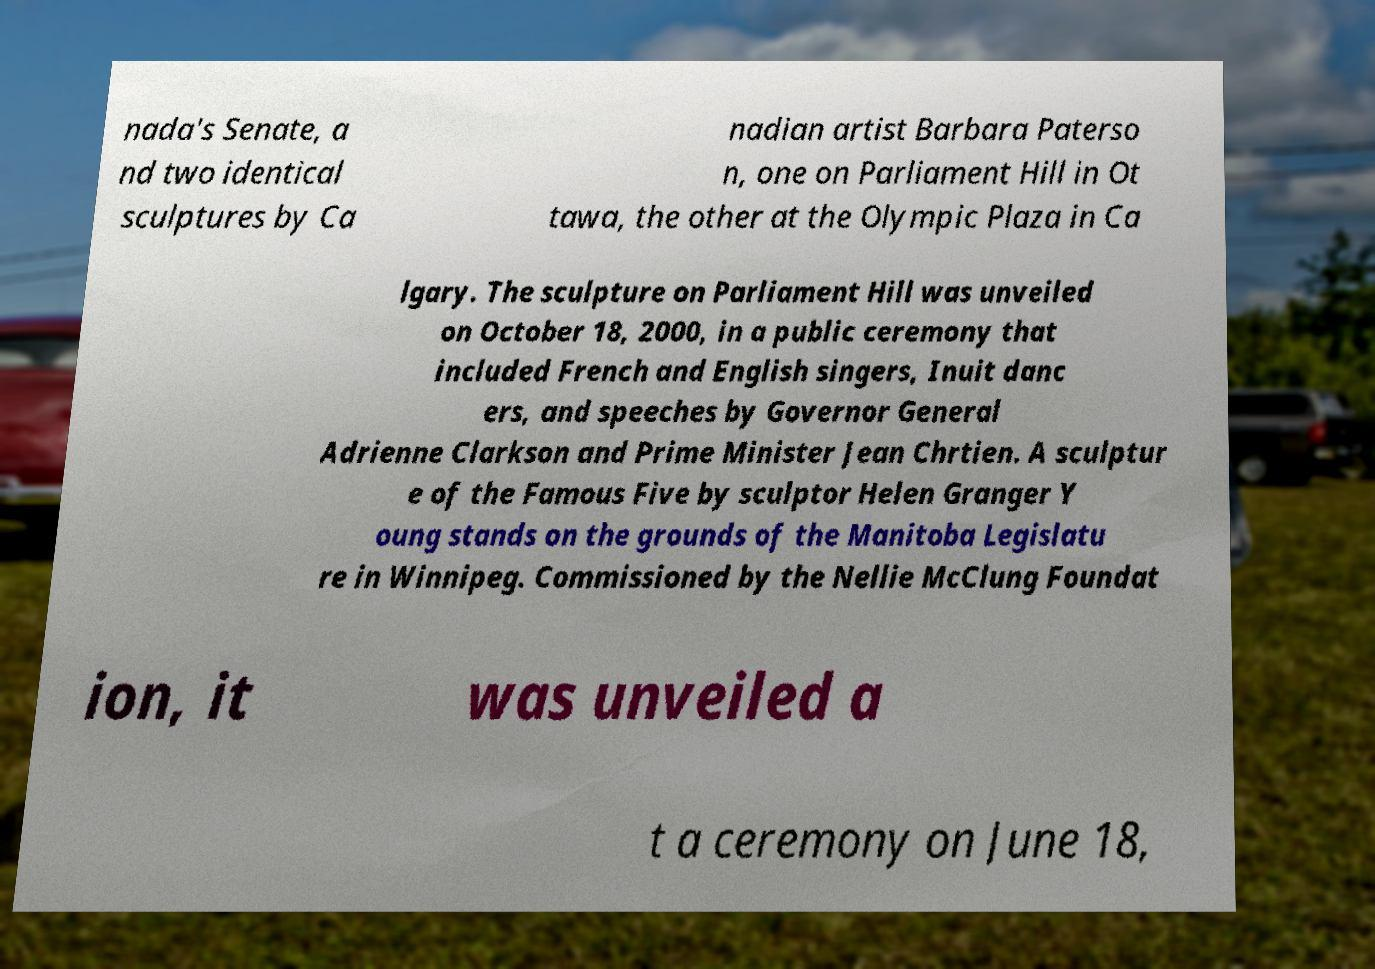I need the written content from this picture converted into text. Can you do that? nada's Senate, a nd two identical sculptures by Ca nadian artist Barbara Paterso n, one on Parliament Hill in Ot tawa, the other at the Olympic Plaza in Ca lgary. The sculpture on Parliament Hill was unveiled on October 18, 2000, in a public ceremony that included French and English singers, Inuit danc ers, and speeches by Governor General Adrienne Clarkson and Prime Minister Jean Chrtien. A sculptur e of the Famous Five by sculptor Helen Granger Y oung stands on the grounds of the Manitoba Legislatu re in Winnipeg. Commissioned by the Nellie McClung Foundat ion, it was unveiled a t a ceremony on June 18, 